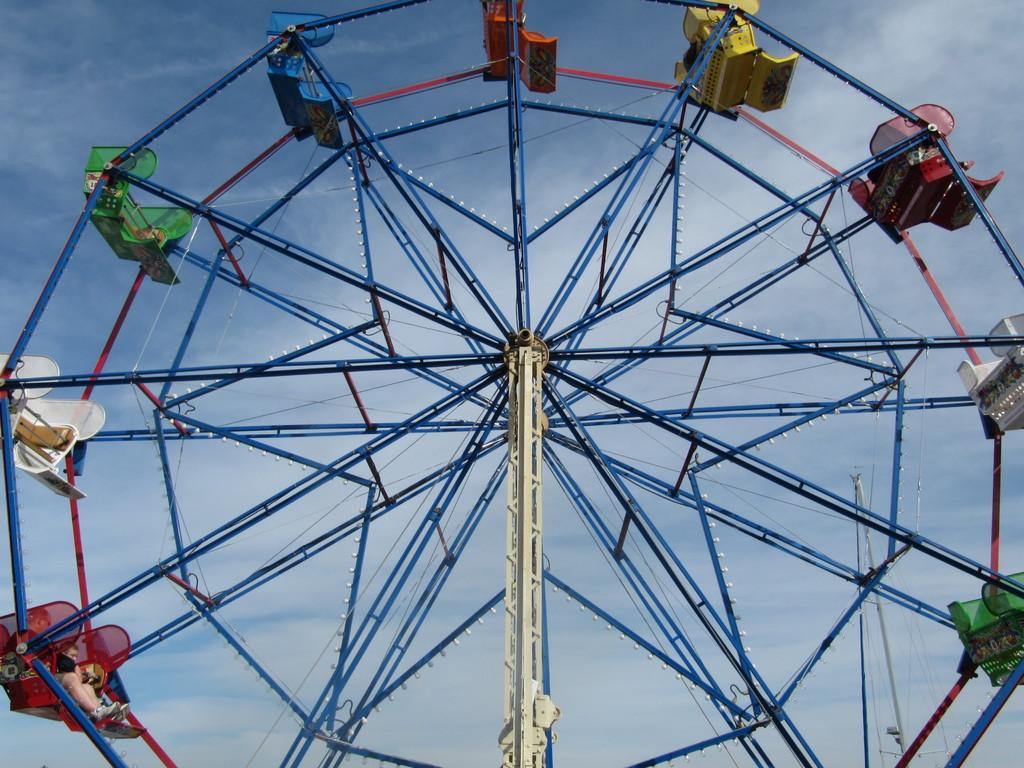What is the main subject of the image? The main subject of the image is a giant wheel. What can be seen in the background of the image? The sky is visible in the background of the image. What page of the book is the giant wheel located on in the image? There is no book or page present in the image; it features a giant wheel and the sky. What season is depicted in the image? The image does not depict a specific season, as there are no seasonal cues present. 